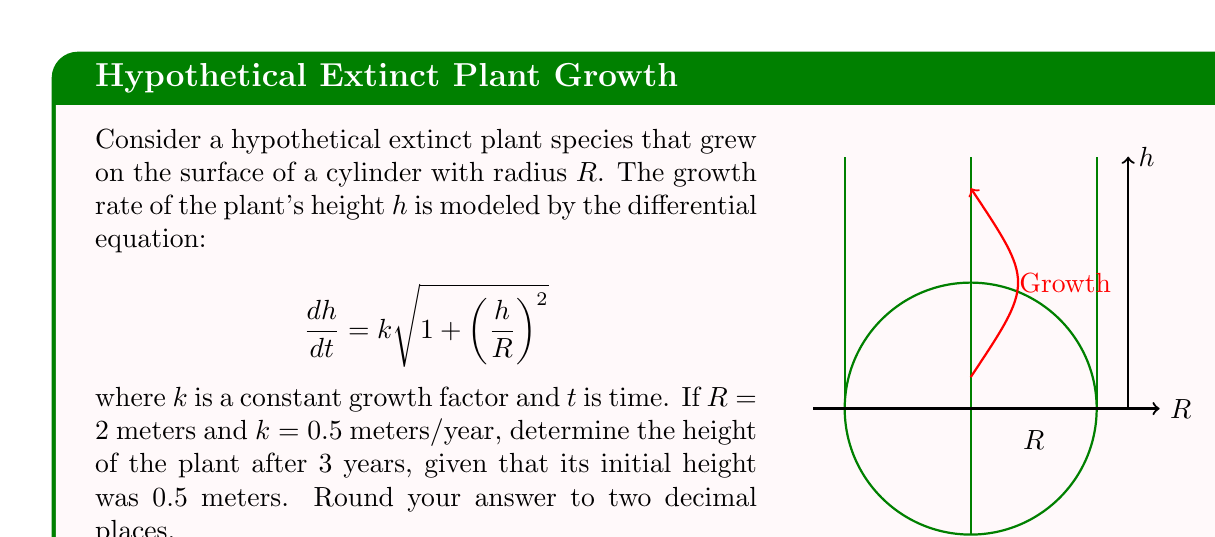Can you answer this question? Let's approach this problem step-by-step:

1) We're given the differential equation:

   $$\frac{dh}{dt} = k\sqrt{1 + \left(\frac{h}{R}\right)^2}$$

2) We're also given that $R = 2$ meters and $k = 0.5$ meters/year. Let's substitute these values:

   $$\frac{dh}{dt} = 0.5\sqrt{1 + \left(\frac{h}{2}\right)^2}$$

3) This is a separable differential equation. Let's separate the variables:

   $$\frac{dh}{\sqrt{1 + \left(\frac{h}{2}\right)^2}} = 0.5dt$$

4) Integrating both sides:

   $$\int \frac{dh}{\sqrt{1 + \left(\frac{h}{2}\right)^2}} = \int 0.5dt$$

5) The left side is a standard integral that results in $2\sinh^{-1}(\frac{h}{2})$. So we get:

   $$2\sinh^{-1}\left(\frac{h}{2}\right) = 0.5t + C$$

6) To find $C$, we use the initial condition: when $t=0$, $h=0.5$. Substituting:

   $$2\sinh^{-1}\left(\frac{0.5}{2}\right) = 0 + C$$
   $$C = 2\sinh^{-1}(0.25) \approx 0.5033$$

7) Now our equation is:

   $$2\sinh^{-1}\left(\frac{h}{2}\right) = 0.5t + 0.5033$$

8) To find $h$ after 3 years, we substitute $t=3$:

   $$2\sinh^{-1}\left(\frac{h}{2}\right) = 0.5(3) + 0.5033 = 2.0033$$

9) Solving for $h$:

   $$\sinh^{-1}\left(\frac{h}{2}\right) = 1.00165$$
   $$\frac{h}{2} = \sinh(1.00165)$$
   $$h = 2\sinh(1.00165) \approx 2.38$$

Therefore, after 3 years, the plant's height is approximately 2.38 meters.
Answer: 2.38 meters 